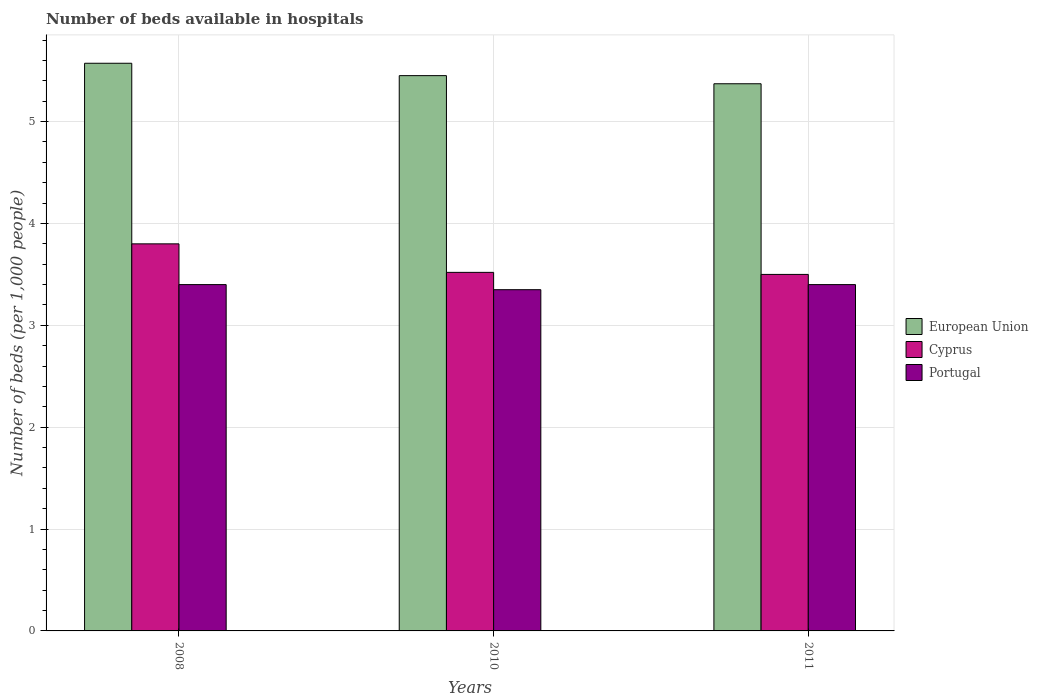Are the number of bars on each tick of the X-axis equal?
Offer a very short reply. Yes. How many bars are there on the 3rd tick from the left?
Provide a succinct answer. 3. How many bars are there on the 2nd tick from the right?
Your response must be concise. 3. Across all years, what is the maximum number of beds in the hospiatls of in Cyprus?
Provide a short and direct response. 3.8. Across all years, what is the minimum number of beds in the hospiatls of in European Union?
Ensure brevity in your answer.  5.37. What is the total number of beds in the hospiatls of in Portugal in the graph?
Provide a succinct answer. 10.15. What is the difference between the number of beds in the hospiatls of in European Union in 2008 and that in 2010?
Make the answer very short. 0.12. What is the difference between the number of beds in the hospiatls of in Portugal in 2008 and the number of beds in the hospiatls of in Cyprus in 2010?
Provide a short and direct response. -0.12. What is the average number of beds in the hospiatls of in European Union per year?
Offer a very short reply. 5.47. In the year 2010, what is the difference between the number of beds in the hospiatls of in Cyprus and number of beds in the hospiatls of in Portugal?
Provide a succinct answer. 0.17. In how many years, is the number of beds in the hospiatls of in European Union greater than 1.4?
Provide a succinct answer. 3. What is the ratio of the number of beds in the hospiatls of in Portugal in 2008 to that in 2011?
Keep it short and to the point. 1. Is the number of beds in the hospiatls of in European Union in 2008 less than that in 2011?
Your answer should be compact. No. What is the difference between the highest and the second highest number of beds in the hospiatls of in European Union?
Give a very brief answer. 0.12. What is the difference between the highest and the lowest number of beds in the hospiatls of in European Union?
Make the answer very short. 0.2. In how many years, is the number of beds in the hospiatls of in Portugal greater than the average number of beds in the hospiatls of in Portugal taken over all years?
Offer a terse response. 2. What does the 3rd bar from the left in 2011 represents?
Offer a very short reply. Portugal. What does the 1st bar from the right in 2008 represents?
Your answer should be very brief. Portugal. Is it the case that in every year, the sum of the number of beds in the hospiatls of in Cyprus and number of beds in the hospiatls of in Portugal is greater than the number of beds in the hospiatls of in European Union?
Offer a terse response. Yes. How many bars are there?
Your response must be concise. 9. What is the difference between two consecutive major ticks on the Y-axis?
Offer a terse response. 1. Where does the legend appear in the graph?
Keep it short and to the point. Center right. What is the title of the graph?
Keep it short and to the point. Number of beds available in hospitals. Does "Kuwait" appear as one of the legend labels in the graph?
Make the answer very short. No. What is the label or title of the X-axis?
Make the answer very short. Years. What is the label or title of the Y-axis?
Provide a short and direct response. Number of beds (per 1,0 people). What is the Number of beds (per 1,000 people) in European Union in 2008?
Offer a terse response. 5.57. What is the Number of beds (per 1,000 people) of Portugal in 2008?
Ensure brevity in your answer.  3.4. What is the Number of beds (per 1,000 people) of European Union in 2010?
Provide a short and direct response. 5.45. What is the Number of beds (per 1,000 people) of Cyprus in 2010?
Offer a very short reply. 3.52. What is the Number of beds (per 1,000 people) in Portugal in 2010?
Your answer should be compact. 3.35. What is the Number of beds (per 1,000 people) in European Union in 2011?
Provide a succinct answer. 5.37. What is the Number of beds (per 1,000 people) in Cyprus in 2011?
Make the answer very short. 3.5. Across all years, what is the maximum Number of beds (per 1,000 people) in European Union?
Provide a short and direct response. 5.57. Across all years, what is the maximum Number of beds (per 1,000 people) in Portugal?
Keep it short and to the point. 3.4. Across all years, what is the minimum Number of beds (per 1,000 people) of European Union?
Provide a short and direct response. 5.37. Across all years, what is the minimum Number of beds (per 1,000 people) in Cyprus?
Provide a short and direct response. 3.5. Across all years, what is the minimum Number of beds (per 1,000 people) of Portugal?
Your answer should be compact. 3.35. What is the total Number of beds (per 1,000 people) of European Union in the graph?
Your response must be concise. 16.4. What is the total Number of beds (per 1,000 people) of Cyprus in the graph?
Your response must be concise. 10.82. What is the total Number of beds (per 1,000 people) in Portugal in the graph?
Offer a very short reply. 10.15. What is the difference between the Number of beds (per 1,000 people) in European Union in 2008 and that in 2010?
Provide a succinct answer. 0.12. What is the difference between the Number of beds (per 1,000 people) of Cyprus in 2008 and that in 2010?
Your response must be concise. 0.28. What is the difference between the Number of beds (per 1,000 people) of European Union in 2008 and that in 2011?
Offer a terse response. 0.2. What is the difference between the Number of beds (per 1,000 people) of Cyprus in 2008 and that in 2011?
Ensure brevity in your answer.  0.3. What is the difference between the Number of beds (per 1,000 people) in Portugal in 2008 and that in 2011?
Keep it short and to the point. 0. What is the difference between the Number of beds (per 1,000 people) in European Union in 2010 and that in 2011?
Provide a succinct answer. 0.08. What is the difference between the Number of beds (per 1,000 people) in Cyprus in 2010 and that in 2011?
Ensure brevity in your answer.  0.02. What is the difference between the Number of beds (per 1,000 people) of Portugal in 2010 and that in 2011?
Ensure brevity in your answer.  -0.05. What is the difference between the Number of beds (per 1,000 people) of European Union in 2008 and the Number of beds (per 1,000 people) of Cyprus in 2010?
Make the answer very short. 2.05. What is the difference between the Number of beds (per 1,000 people) in European Union in 2008 and the Number of beds (per 1,000 people) in Portugal in 2010?
Make the answer very short. 2.22. What is the difference between the Number of beds (per 1,000 people) of Cyprus in 2008 and the Number of beds (per 1,000 people) of Portugal in 2010?
Offer a very short reply. 0.45. What is the difference between the Number of beds (per 1,000 people) of European Union in 2008 and the Number of beds (per 1,000 people) of Cyprus in 2011?
Keep it short and to the point. 2.07. What is the difference between the Number of beds (per 1,000 people) in European Union in 2008 and the Number of beds (per 1,000 people) in Portugal in 2011?
Ensure brevity in your answer.  2.17. What is the difference between the Number of beds (per 1,000 people) of Cyprus in 2008 and the Number of beds (per 1,000 people) of Portugal in 2011?
Your response must be concise. 0.4. What is the difference between the Number of beds (per 1,000 people) in European Union in 2010 and the Number of beds (per 1,000 people) in Cyprus in 2011?
Offer a terse response. 1.95. What is the difference between the Number of beds (per 1,000 people) of European Union in 2010 and the Number of beds (per 1,000 people) of Portugal in 2011?
Your response must be concise. 2.05. What is the difference between the Number of beds (per 1,000 people) in Cyprus in 2010 and the Number of beds (per 1,000 people) in Portugal in 2011?
Give a very brief answer. 0.12. What is the average Number of beds (per 1,000 people) of European Union per year?
Your answer should be very brief. 5.47. What is the average Number of beds (per 1,000 people) of Cyprus per year?
Your answer should be compact. 3.61. What is the average Number of beds (per 1,000 people) of Portugal per year?
Make the answer very short. 3.38. In the year 2008, what is the difference between the Number of beds (per 1,000 people) in European Union and Number of beds (per 1,000 people) in Cyprus?
Make the answer very short. 1.77. In the year 2008, what is the difference between the Number of beds (per 1,000 people) of European Union and Number of beds (per 1,000 people) of Portugal?
Provide a short and direct response. 2.17. In the year 2008, what is the difference between the Number of beds (per 1,000 people) of Cyprus and Number of beds (per 1,000 people) of Portugal?
Keep it short and to the point. 0.4. In the year 2010, what is the difference between the Number of beds (per 1,000 people) of European Union and Number of beds (per 1,000 people) of Cyprus?
Offer a very short reply. 1.93. In the year 2010, what is the difference between the Number of beds (per 1,000 people) in European Union and Number of beds (per 1,000 people) in Portugal?
Give a very brief answer. 2.1. In the year 2010, what is the difference between the Number of beds (per 1,000 people) in Cyprus and Number of beds (per 1,000 people) in Portugal?
Your response must be concise. 0.17. In the year 2011, what is the difference between the Number of beds (per 1,000 people) of European Union and Number of beds (per 1,000 people) of Cyprus?
Offer a very short reply. 1.87. In the year 2011, what is the difference between the Number of beds (per 1,000 people) in European Union and Number of beds (per 1,000 people) in Portugal?
Make the answer very short. 1.97. In the year 2011, what is the difference between the Number of beds (per 1,000 people) of Cyprus and Number of beds (per 1,000 people) of Portugal?
Offer a terse response. 0.1. What is the ratio of the Number of beds (per 1,000 people) of European Union in 2008 to that in 2010?
Offer a very short reply. 1.02. What is the ratio of the Number of beds (per 1,000 people) in Cyprus in 2008 to that in 2010?
Ensure brevity in your answer.  1.08. What is the ratio of the Number of beds (per 1,000 people) of Portugal in 2008 to that in 2010?
Offer a very short reply. 1.01. What is the ratio of the Number of beds (per 1,000 people) of European Union in 2008 to that in 2011?
Your response must be concise. 1.04. What is the ratio of the Number of beds (per 1,000 people) of Cyprus in 2008 to that in 2011?
Make the answer very short. 1.09. What is the ratio of the Number of beds (per 1,000 people) of European Union in 2010 to that in 2011?
Your answer should be compact. 1.01. What is the ratio of the Number of beds (per 1,000 people) in Cyprus in 2010 to that in 2011?
Give a very brief answer. 1.01. What is the ratio of the Number of beds (per 1,000 people) of Portugal in 2010 to that in 2011?
Give a very brief answer. 0.99. What is the difference between the highest and the second highest Number of beds (per 1,000 people) in European Union?
Give a very brief answer. 0.12. What is the difference between the highest and the second highest Number of beds (per 1,000 people) in Cyprus?
Your answer should be very brief. 0.28. What is the difference between the highest and the lowest Number of beds (per 1,000 people) in European Union?
Your response must be concise. 0.2. What is the difference between the highest and the lowest Number of beds (per 1,000 people) of Portugal?
Your answer should be compact. 0.05. 